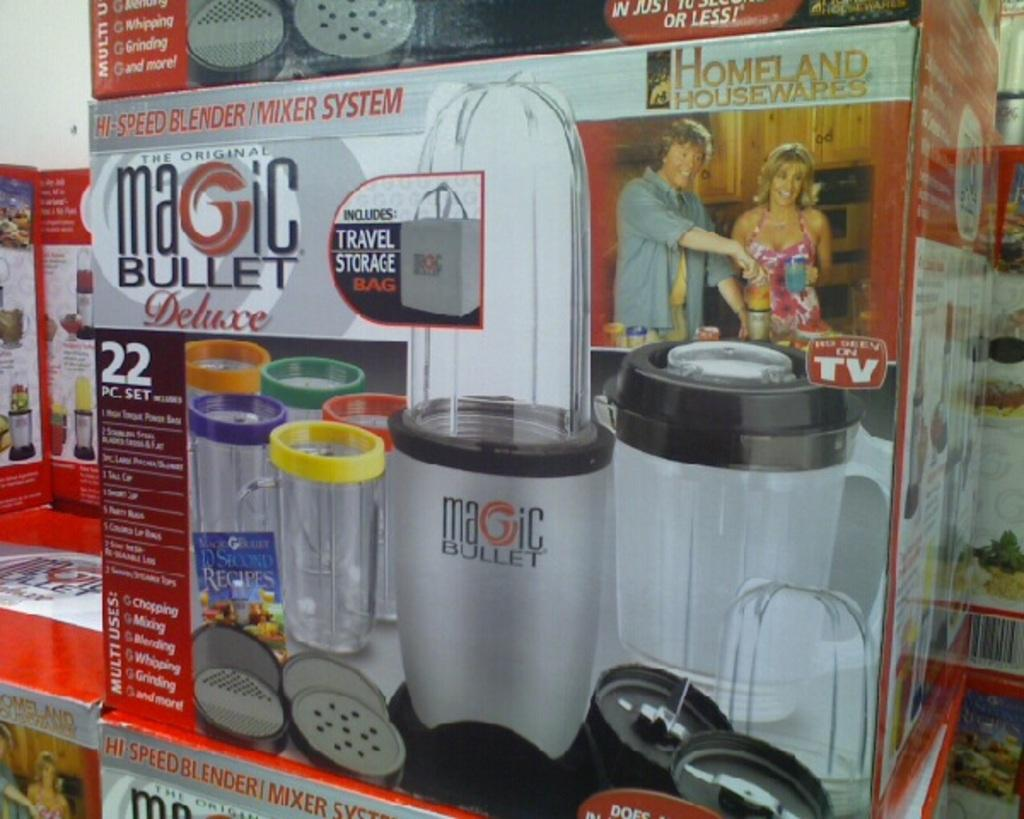<image>
Present a compact description of the photo's key features. A Magic Bullet Deluxe box sits on another box. 